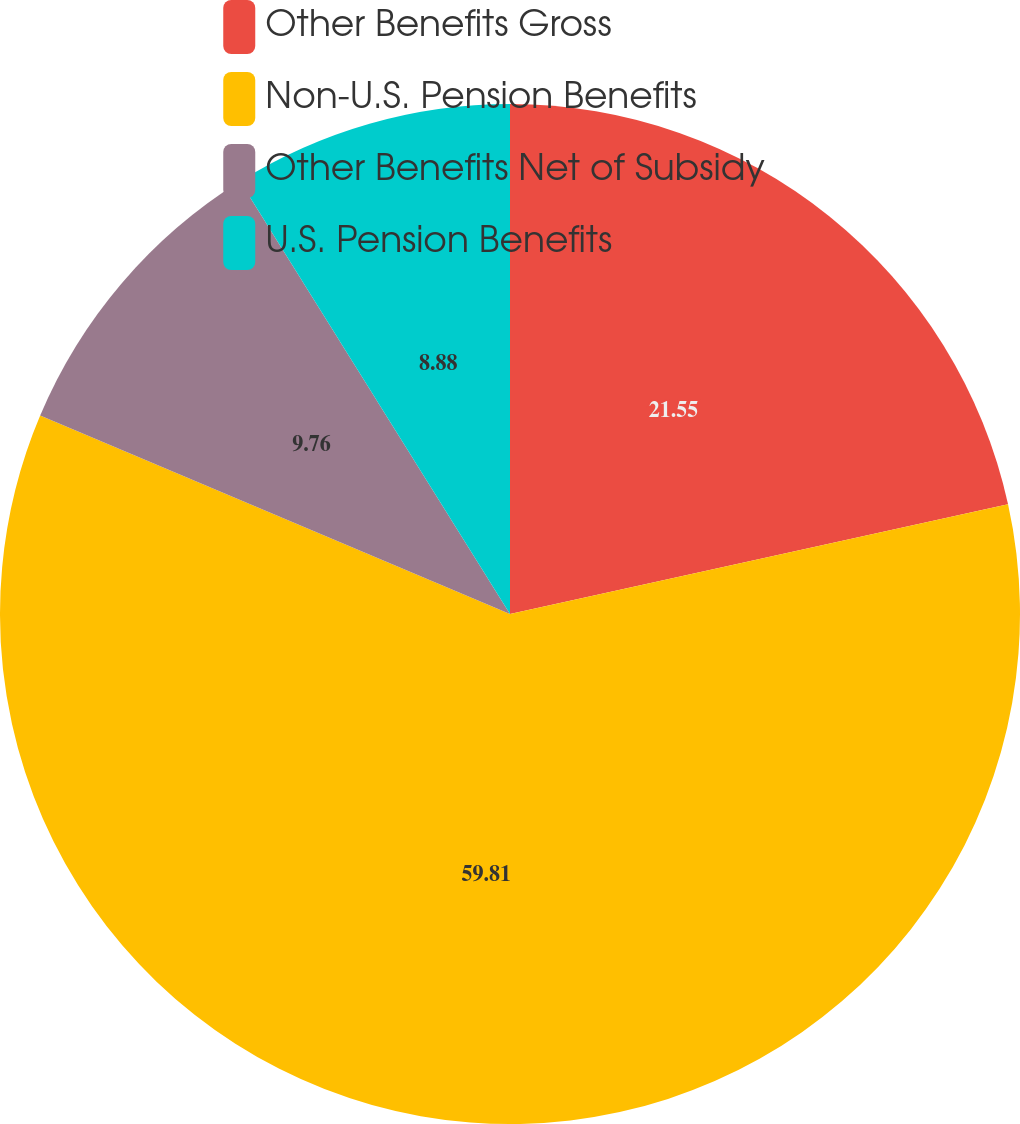<chart> <loc_0><loc_0><loc_500><loc_500><pie_chart><fcel>Other Benefits Gross<fcel>Non-U.S. Pension Benefits<fcel>Other Benefits Net of Subsidy<fcel>U.S. Pension Benefits<nl><fcel>21.55%<fcel>59.81%<fcel>9.76%<fcel>8.88%<nl></chart> 